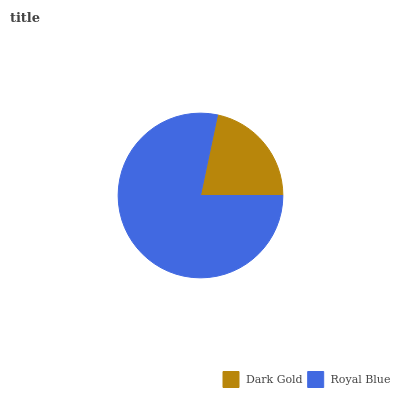Is Dark Gold the minimum?
Answer yes or no. Yes. Is Royal Blue the maximum?
Answer yes or no. Yes. Is Royal Blue the minimum?
Answer yes or no. No. Is Royal Blue greater than Dark Gold?
Answer yes or no. Yes. Is Dark Gold less than Royal Blue?
Answer yes or no. Yes. Is Dark Gold greater than Royal Blue?
Answer yes or no. No. Is Royal Blue less than Dark Gold?
Answer yes or no. No. Is Royal Blue the high median?
Answer yes or no. Yes. Is Dark Gold the low median?
Answer yes or no. Yes. Is Dark Gold the high median?
Answer yes or no. No. Is Royal Blue the low median?
Answer yes or no. No. 